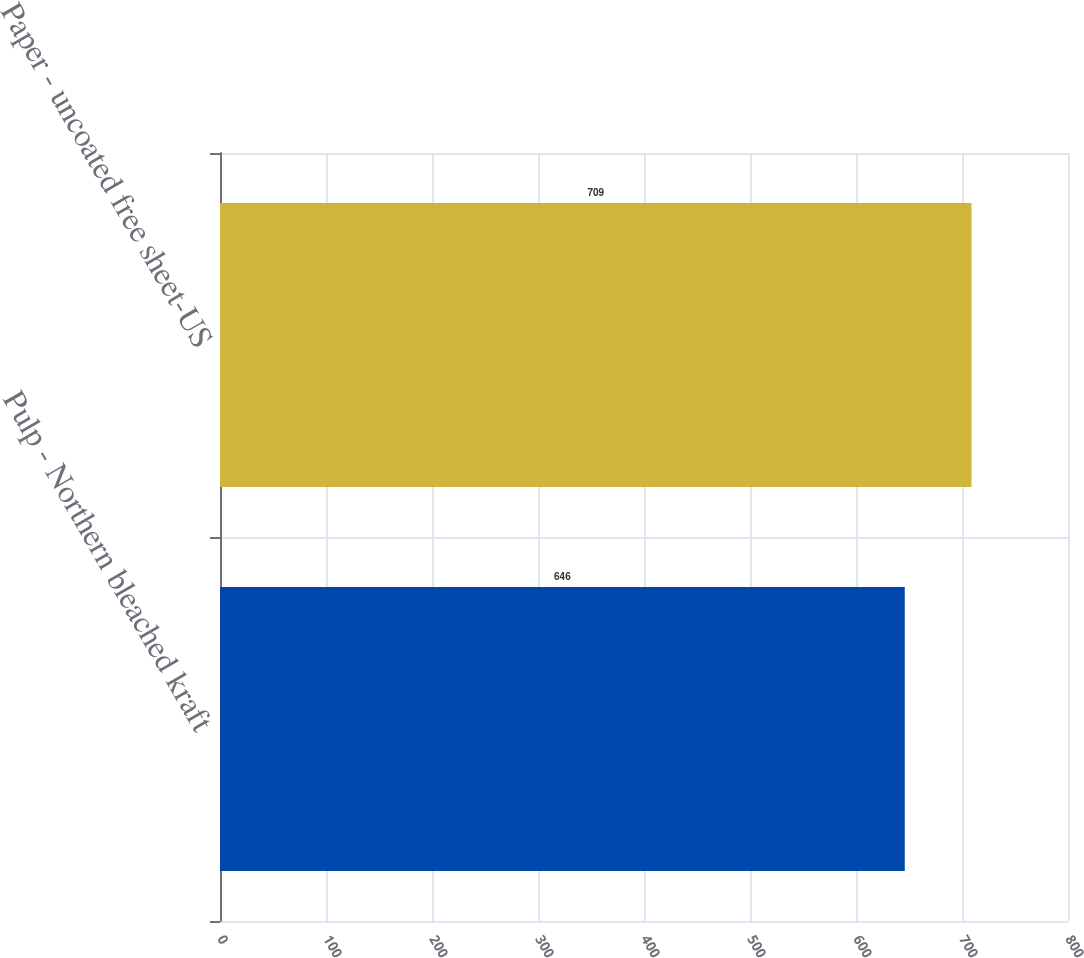Convert chart. <chart><loc_0><loc_0><loc_500><loc_500><bar_chart><fcel>Pulp - Northern bleached kraft<fcel>Paper - uncoated free sheet-US<nl><fcel>646<fcel>709<nl></chart> 